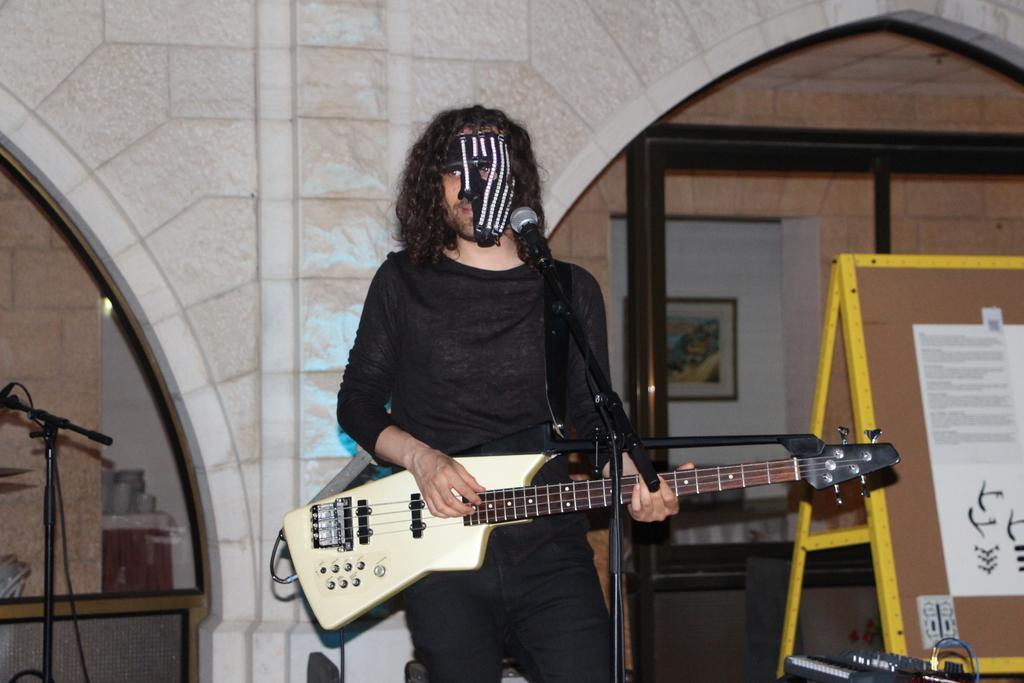Describe this image in one or two sentences. In this image a person is standing. He is holding a guitar. He is wearing a mask. Before him there is a mike stand. Right side there is a board having few posts attached to it. Right bottom there is an electrical device. Left side there is a mike stand. A picture frame is attached to the wall. 